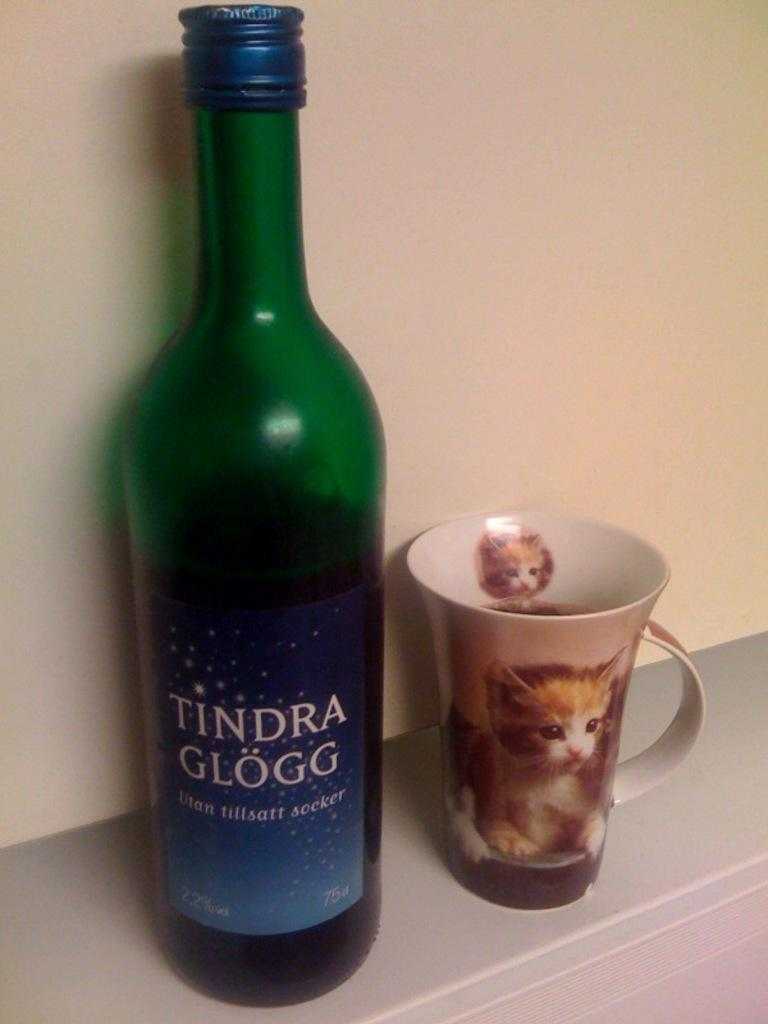What objects are on the table in the image? There is a bottle and a cup on the table in the image. What is the background of the image? There is a wall in the background of the image. What sign of disgust can be seen on the bottle in the image? There is no sign of disgust present on the bottle in the image. 